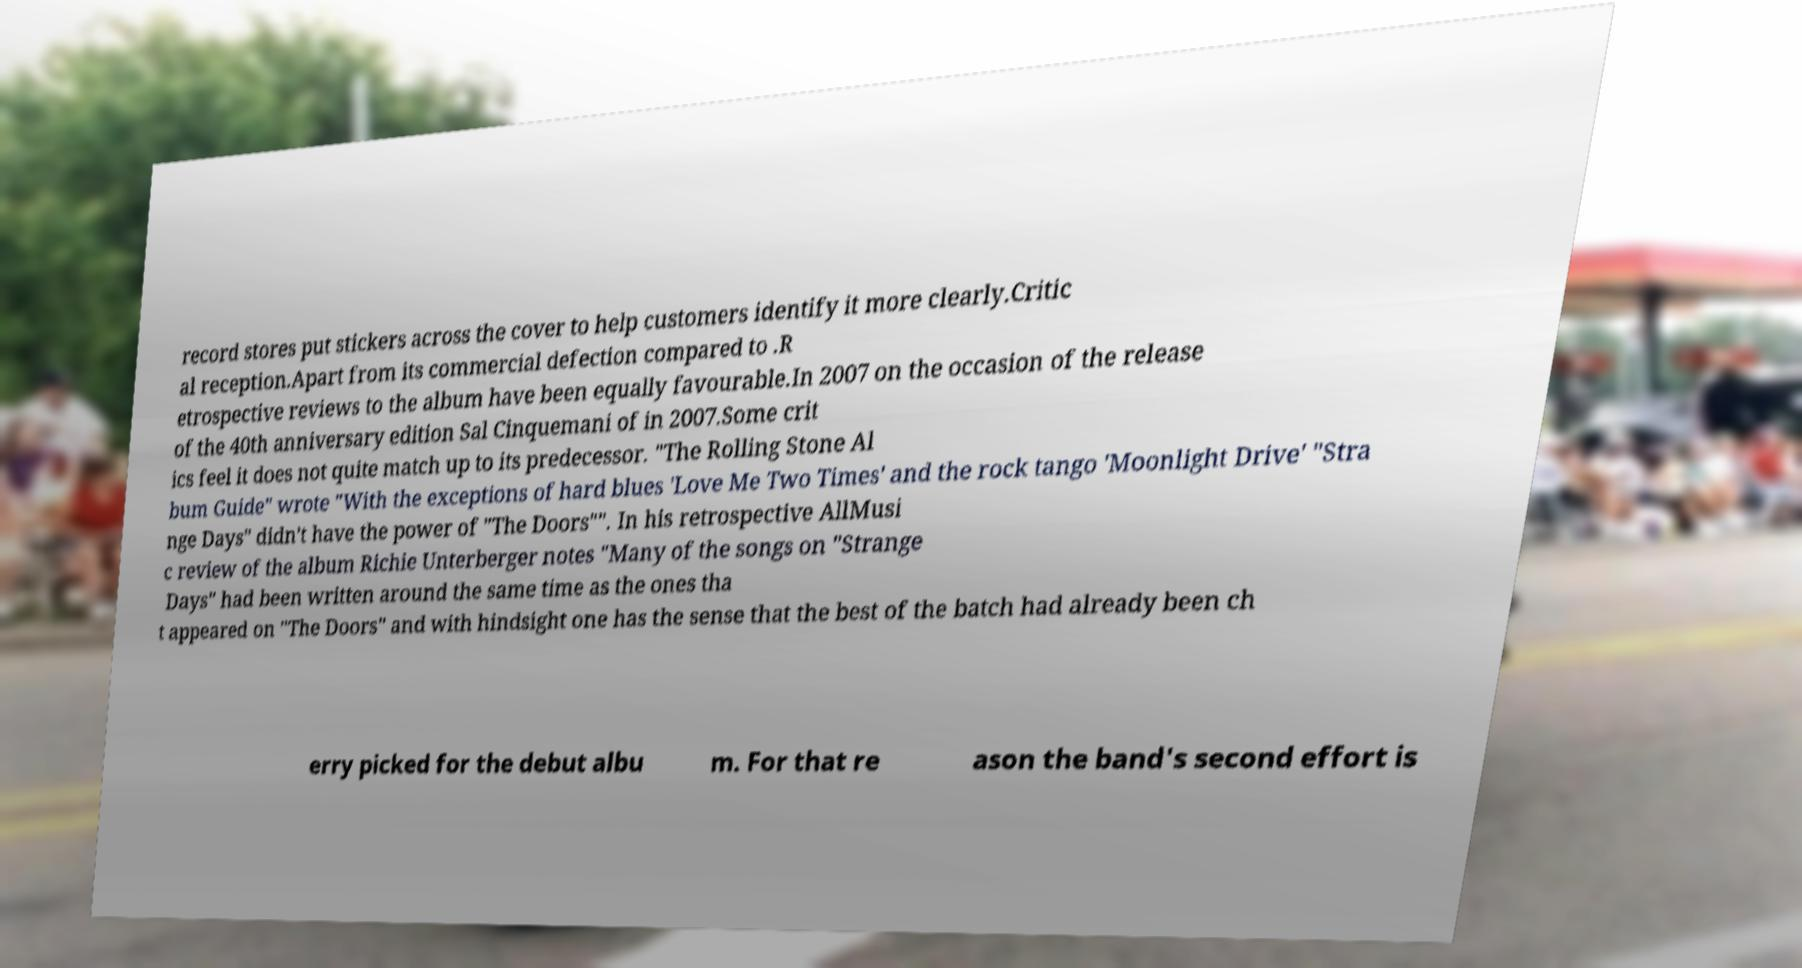Could you extract and type out the text from this image? record stores put stickers across the cover to help customers identify it more clearly.Critic al reception.Apart from its commercial defection compared to .R etrospective reviews to the album have been equally favourable.In 2007 on the occasion of the release of the 40th anniversary edition Sal Cinquemani of in 2007.Some crit ics feel it does not quite match up to its predecessor. "The Rolling Stone Al bum Guide" wrote "With the exceptions of hard blues 'Love Me Two Times' and the rock tango 'Moonlight Drive' "Stra nge Days" didn't have the power of "The Doors"". In his retrospective AllMusi c review of the album Richie Unterberger notes "Many of the songs on "Strange Days" had been written around the same time as the ones tha t appeared on "The Doors" and with hindsight one has the sense that the best of the batch had already been ch erry picked for the debut albu m. For that re ason the band's second effort is 